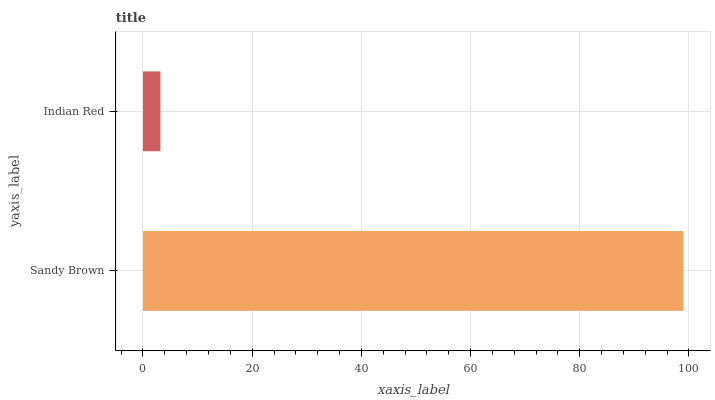Is Indian Red the minimum?
Answer yes or no. Yes. Is Sandy Brown the maximum?
Answer yes or no. Yes. Is Indian Red the maximum?
Answer yes or no. No. Is Sandy Brown greater than Indian Red?
Answer yes or no. Yes. Is Indian Red less than Sandy Brown?
Answer yes or no. Yes. Is Indian Red greater than Sandy Brown?
Answer yes or no. No. Is Sandy Brown less than Indian Red?
Answer yes or no. No. Is Sandy Brown the high median?
Answer yes or no. Yes. Is Indian Red the low median?
Answer yes or no. Yes. Is Indian Red the high median?
Answer yes or no. No. Is Sandy Brown the low median?
Answer yes or no. No. 